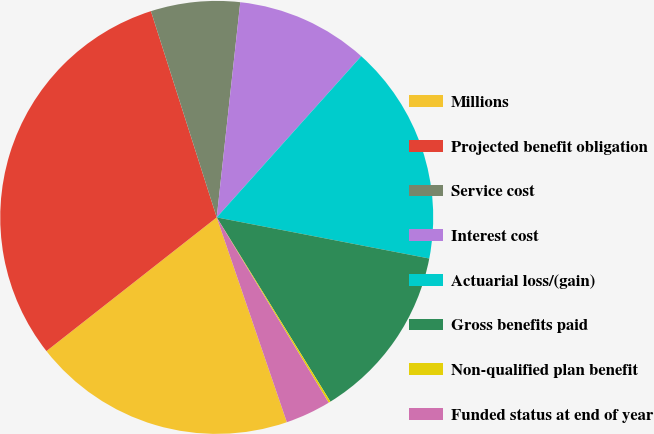Convert chart to OTSL. <chart><loc_0><loc_0><loc_500><loc_500><pie_chart><fcel>Millions<fcel>Projected benefit obligation<fcel>Service cost<fcel>Interest cost<fcel>Actuarial loss/(gain)<fcel>Gross benefits paid<fcel>Non-qualified plan benefit<fcel>Funded status at end of year<nl><fcel>19.66%<fcel>30.68%<fcel>6.65%<fcel>9.9%<fcel>16.41%<fcel>13.16%<fcel>0.15%<fcel>3.4%<nl></chart> 